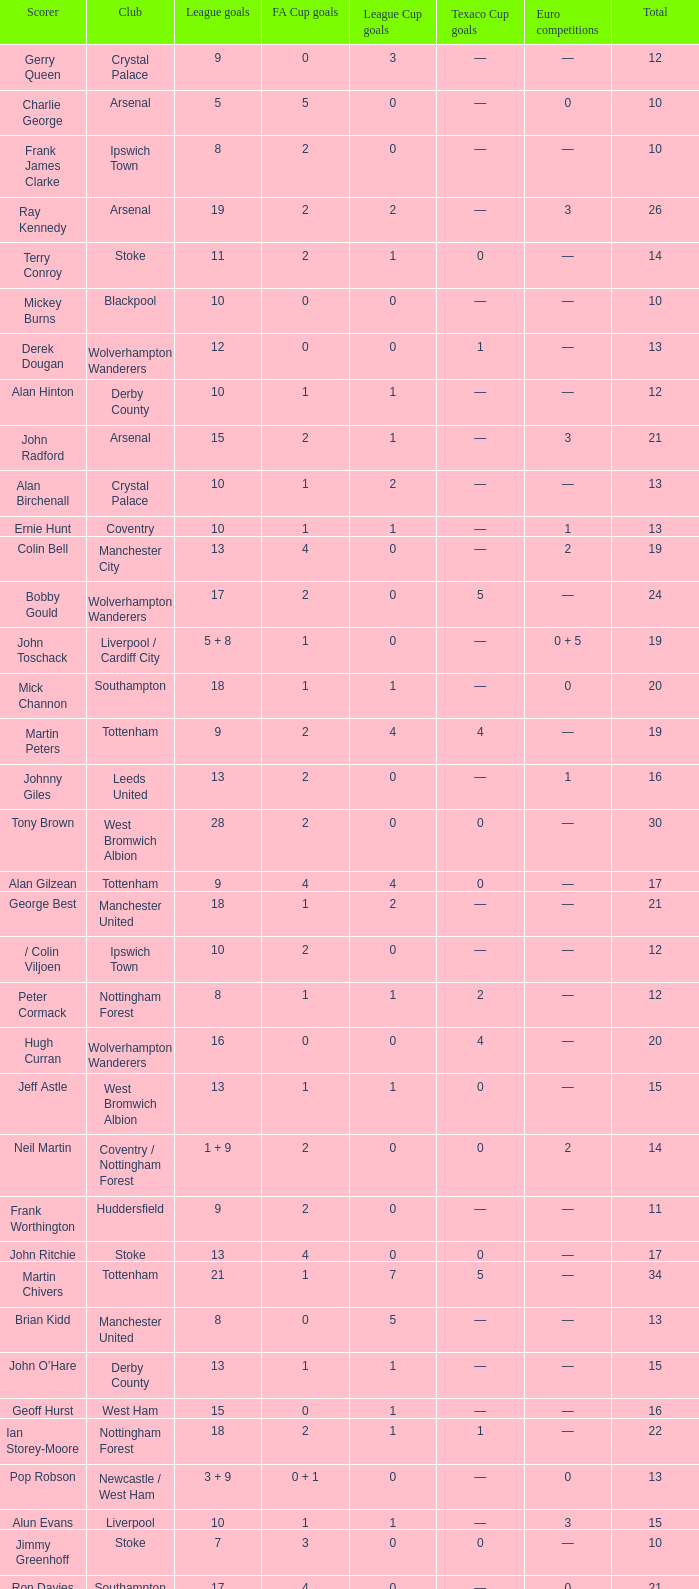What is the lowest League Cup Goals, when Scorer is Denis Law? 1.0. 